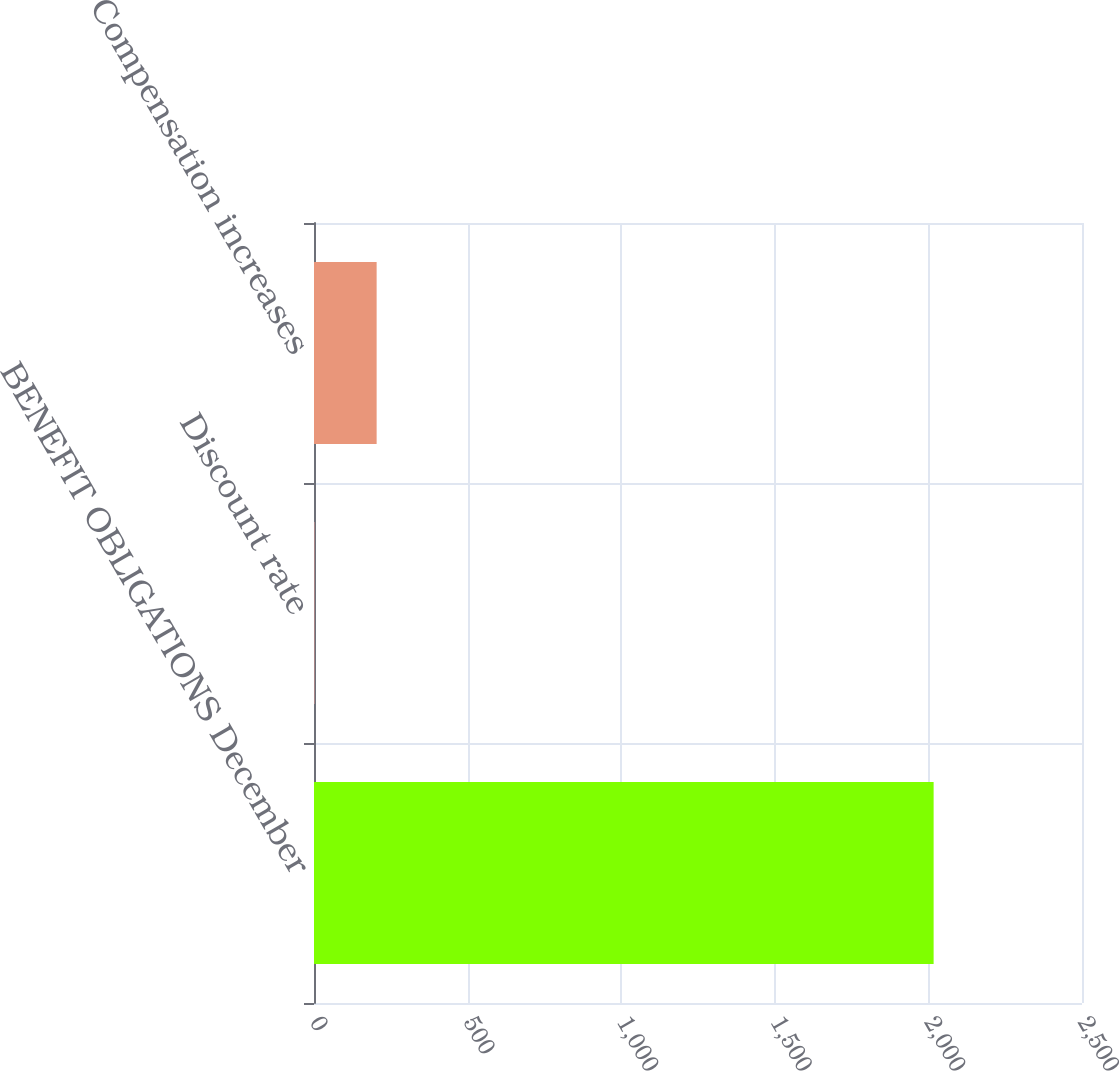Convert chart to OTSL. <chart><loc_0><loc_0><loc_500><loc_500><bar_chart><fcel>BENEFIT OBLIGATIONS December<fcel>Discount rate<fcel>Compensation increases<nl><fcel>2017<fcel>2.45<fcel>203.91<nl></chart> 